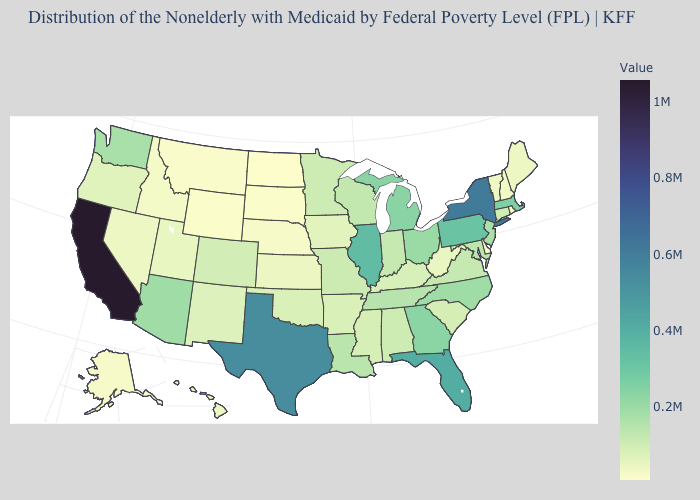Does Wyoming have the lowest value in the West?
Short answer required. Yes. Does North Carolina have the lowest value in the USA?
Be succinct. No. 